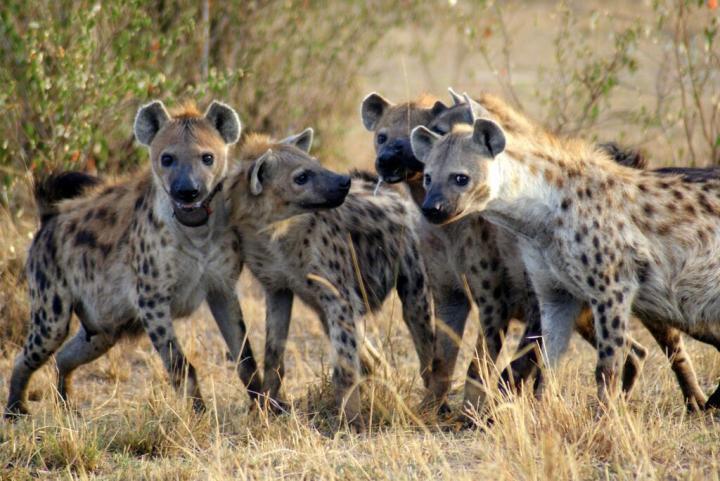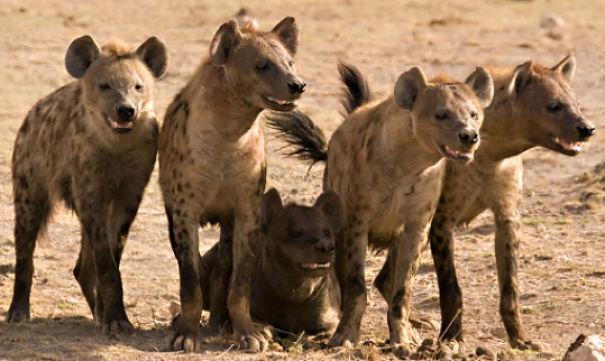The first image is the image on the left, the second image is the image on the right. Considering the images on both sides, is "Some of the animals are eating their prey." valid? Answer yes or no. No. The first image is the image on the left, the second image is the image on the right. Evaluate the accuracy of this statement regarding the images: "At least one image shows hyenas around an animal carcass.". Is it true? Answer yes or no. No. 